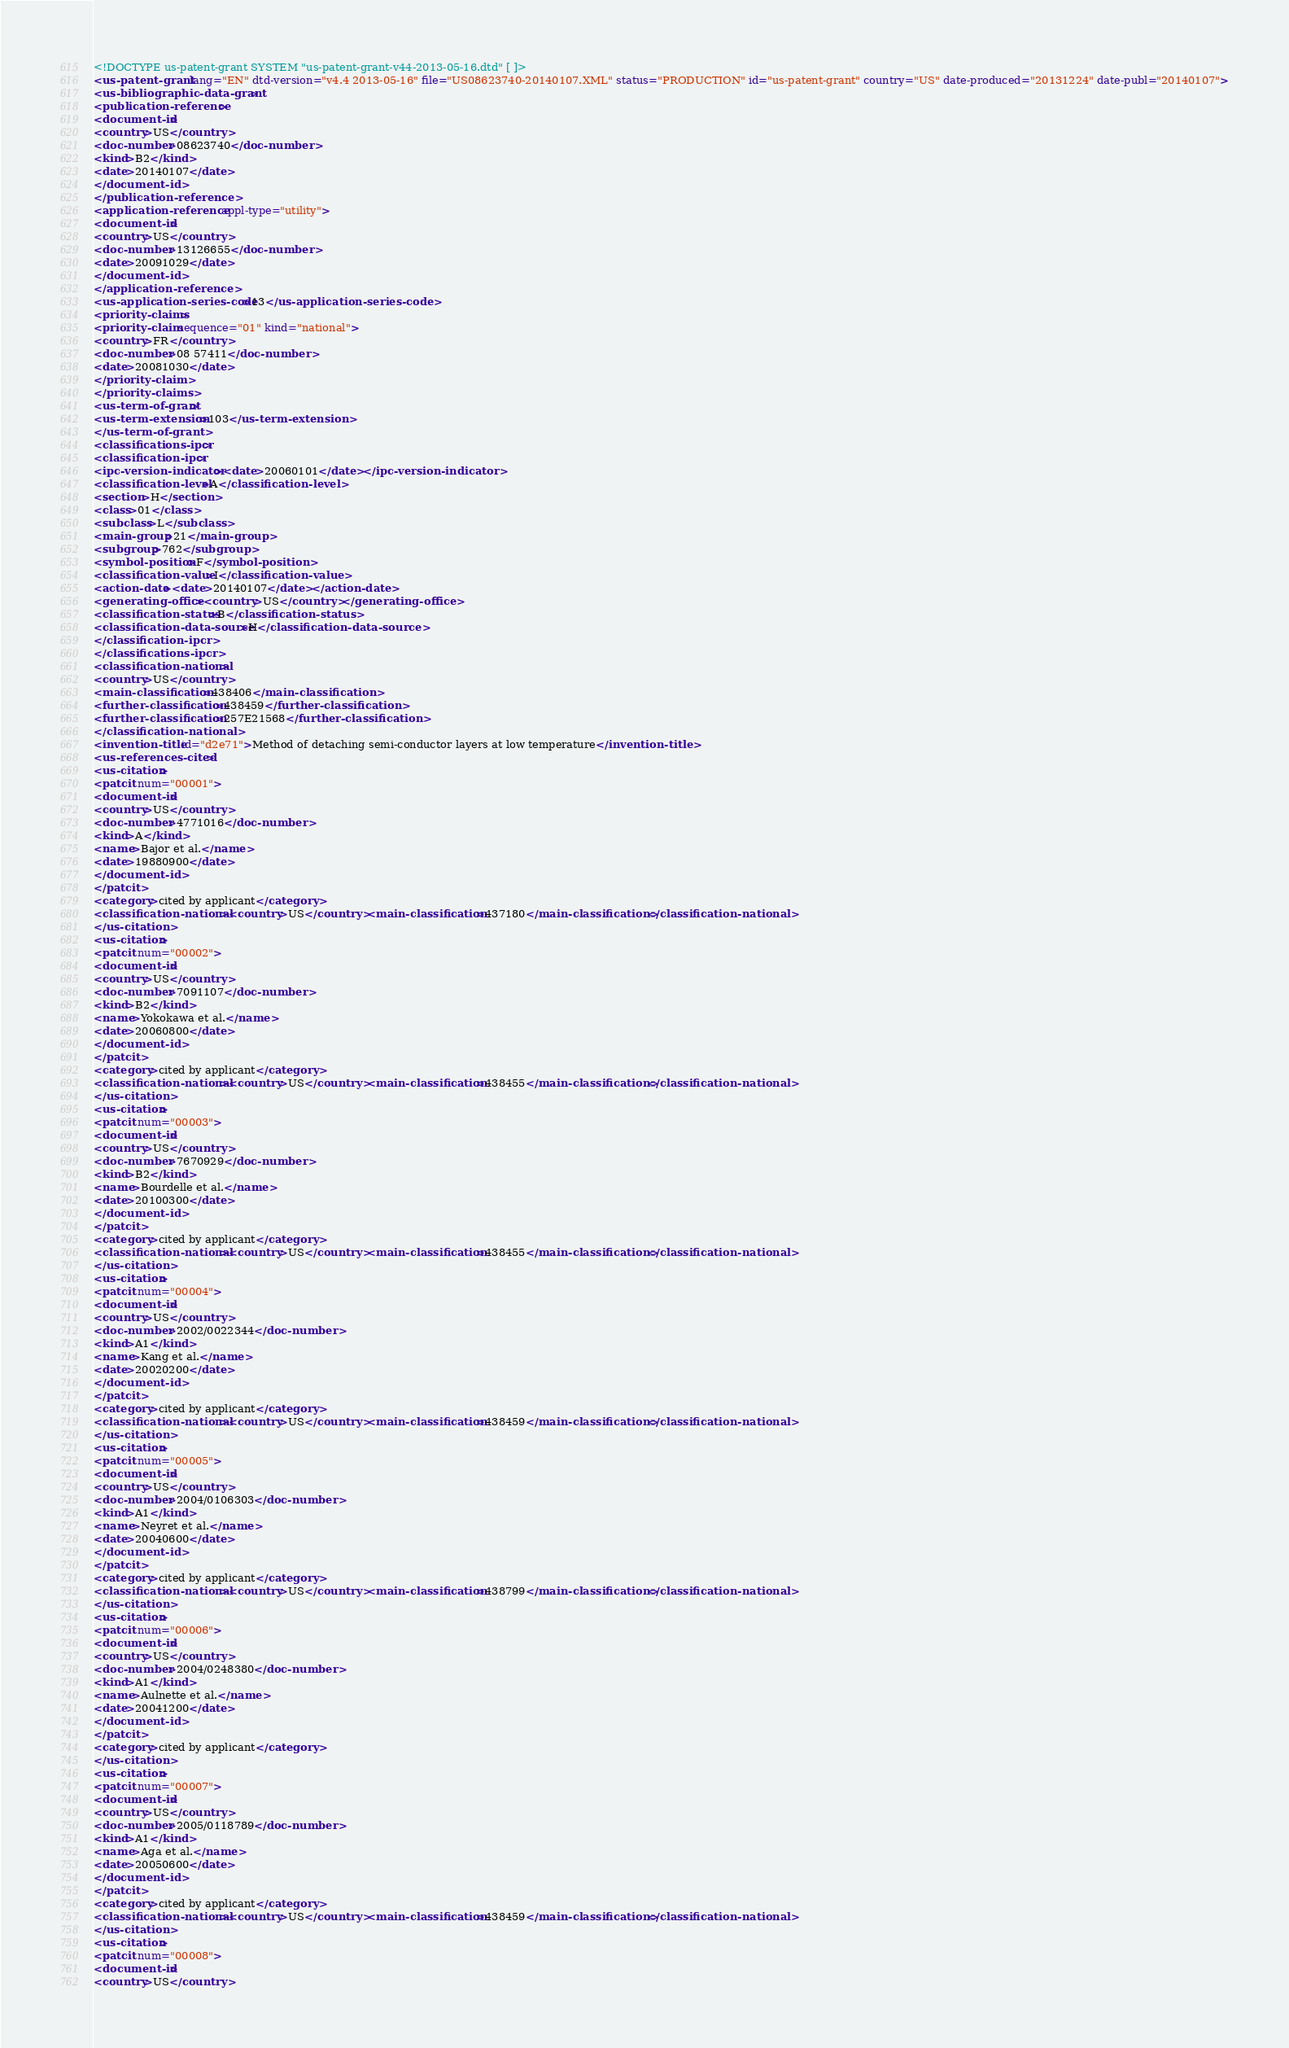Convert code to text. <code><loc_0><loc_0><loc_500><loc_500><_XML_><!DOCTYPE us-patent-grant SYSTEM "us-patent-grant-v44-2013-05-16.dtd" [ ]>
<us-patent-grant lang="EN" dtd-version="v4.4 2013-05-16" file="US08623740-20140107.XML" status="PRODUCTION" id="us-patent-grant" country="US" date-produced="20131224" date-publ="20140107">
<us-bibliographic-data-grant>
<publication-reference>
<document-id>
<country>US</country>
<doc-number>08623740</doc-number>
<kind>B2</kind>
<date>20140107</date>
</document-id>
</publication-reference>
<application-reference appl-type="utility">
<document-id>
<country>US</country>
<doc-number>13126655</doc-number>
<date>20091029</date>
</document-id>
</application-reference>
<us-application-series-code>13</us-application-series-code>
<priority-claims>
<priority-claim sequence="01" kind="national">
<country>FR</country>
<doc-number>08 57411</doc-number>
<date>20081030</date>
</priority-claim>
</priority-claims>
<us-term-of-grant>
<us-term-extension>103</us-term-extension>
</us-term-of-grant>
<classifications-ipcr>
<classification-ipcr>
<ipc-version-indicator><date>20060101</date></ipc-version-indicator>
<classification-level>A</classification-level>
<section>H</section>
<class>01</class>
<subclass>L</subclass>
<main-group>21</main-group>
<subgroup>762</subgroup>
<symbol-position>F</symbol-position>
<classification-value>I</classification-value>
<action-date><date>20140107</date></action-date>
<generating-office><country>US</country></generating-office>
<classification-status>B</classification-status>
<classification-data-source>H</classification-data-source>
</classification-ipcr>
</classifications-ipcr>
<classification-national>
<country>US</country>
<main-classification>438406</main-classification>
<further-classification>438459</further-classification>
<further-classification>257E21568</further-classification>
</classification-national>
<invention-title id="d2e71">Method of detaching semi-conductor layers at low temperature</invention-title>
<us-references-cited>
<us-citation>
<patcit num="00001">
<document-id>
<country>US</country>
<doc-number>4771016</doc-number>
<kind>A</kind>
<name>Bajor et al.</name>
<date>19880900</date>
</document-id>
</patcit>
<category>cited by applicant</category>
<classification-national><country>US</country><main-classification>437180</main-classification></classification-national>
</us-citation>
<us-citation>
<patcit num="00002">
<document-id>
<country>US</country>
<doc-number>7091107</doc-number>
<kind>B2</kind>
<name>Yokokawa et al.</name>
<date>20060800</date>
</document-id>
</patcit>
<category>cited by applicant</category>
<classification-national><country>US</country><main-classification>438455</main-classification></classification-national>
</us-citation>
<us-citation>
<patcit num="00003">
<document-id>
<country>US</country>
<doc-number>7670929</doc-number>
<kind>B2</kind>
<name>Bourdelle et al.</name>
<date>20100300</date>
</document-id>
</patcit>
<category>cited by applicant</category>
<classification-national><country>US</country><main-classification>438455</main-classification></classification-national>
</us-citation>
<us-citation>
<patcit num="00004">
<document-id>
<country>US</country>
<doc-number>2002/0022344</doc-number>
<kind>A1</kind>
<name>Kang et al.</name>
<date>20020200</date>
</document-id>
</patcit>
<category>cited by applicant</category>
<classification-national><country>US</country><main-classification>438459</main-classification></classification-national>
</us-citation>
<us-citation>
<patcit num="00005">
<document-id>
<country>US</country>
<doc-number>2004/0106303</doc-number>
<kind>A1</kind>
<name>Neyret et al.</name>
<date>20040600</date>
</document-id>
</patcit>
<category>cited by applicant</category>
<classification-national><country>US</country><main-classification>438799</main-classification></classification-national>
</us-citation>
<us-citation>
<patcit num="00006">
<document-id>
<country>US</country>
<doc-number>2004/0248380</doc-number>
<kind>A1</kind>
<name>Aulnette et al.</name>
<date>20041200</date>
</document-id>
</patcit>
<category>cited by applicant</category>
</us-citation>
<us-citation>
<patcit num="00007">
<document-id>
<country>US</country>
<doc-number>2005/0118789</doc-number>
<kind>A1</kind>
<name>Aga et al.</name>
<date>20050600</date>
</document-id>
</patcit>
<category>cited by applicant</category>
<classification-national><country>US</country><main-classification>438459</main-classification></classification-national>
</us-citation>
<us-citation>
<patcit num="00008">
<document-id>
<country>US</country></code> 